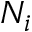Convert formula to latex. <formula><loc_0><loc_0><loc_500><loc_500>N _ { i }</formula> 